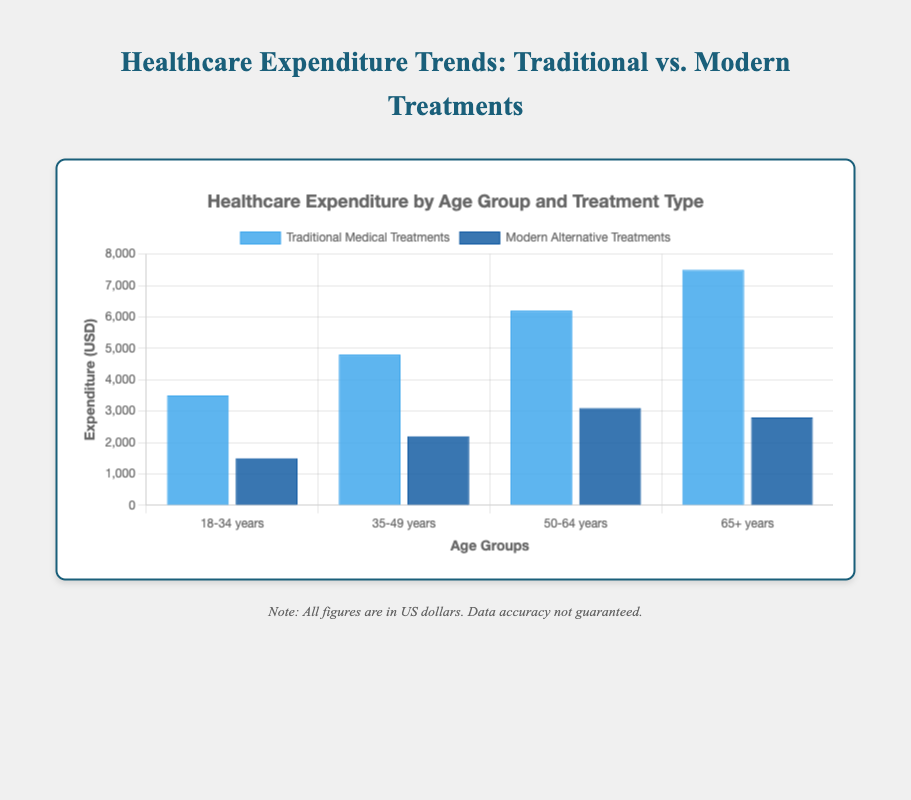Which age group spends the most on traditional medical treatments? Look at the heights of the blue bars for each age group. The bar for the 65+ years group is the tallest for traditional medical treatments, indicating the highest expenditure.
Answer: 65+ years What is the total expenditure on modern alternative treatments across all age groups? Sum the values of the amounts for modern alternative treatments: 1500 + 2200 + 3100 + 2800 = 9600.
Answer: 9600 How much more is spent on traditional medical treatments compared to modern alternative treatments in the 50-64 years age group? Subtract the expenditure on modern alternative treatments from that on traditional medical treatments for the 50-64 years age group: 6200 - 3100 = 3100.
Answer: 3100 Which age group has the smallest difference in expenditure between traditional and modern alternative treatments? Calculate the difference for each age group and compare: 
- 18-34 years: 3500 - 1500 = 2000
- 35-49 years: 4800 - 2200 = 2600
- 50-64 years: 6200 - 3100 = 3100
- 65+ years: 7500 - 2800 = 4700
The smallest difference is for the 18-34 years group.
Answer: 18-34 years What is the average expenditure on traditional medical treatments across all age groups? Sum the expenditure amounts for traditional medical treatments and divide by the number of age groups: (3500 + 4800 + 6200 + 7500) / 4 = 5500.
Answer: 5500 Are there any age groups where expenditure on modern alternative treatments exceeds that on traditional medical treatments? Compare the heights of the bars for each age group. In all age groups, the expenditure on traditional medical treatments (blue bars) is higher than on modern alternative treatments (dark blue bars).
Answer: No Which treatment type has higher overall expenditure for the 18-34 years age group? Compare the heights of the bars for the 18-34 years age group. The blue bar (traditional medical treatments) is higher than the dark blue bar (modern alternative treatments).
Answer: Traditional medical treatments What is the ratio of traditional medical treatment expenditure to modern alternative treatment expenditure for the 35-49 years age group? Calculate the ratio: 4800 / 2200 = 2.18.
Answer: 2.18 Which color represents modern alternative treatments? The dark blue bars represent modern alternative treatments, as indicated by the background color mentioned.
Answer: Dark blue 